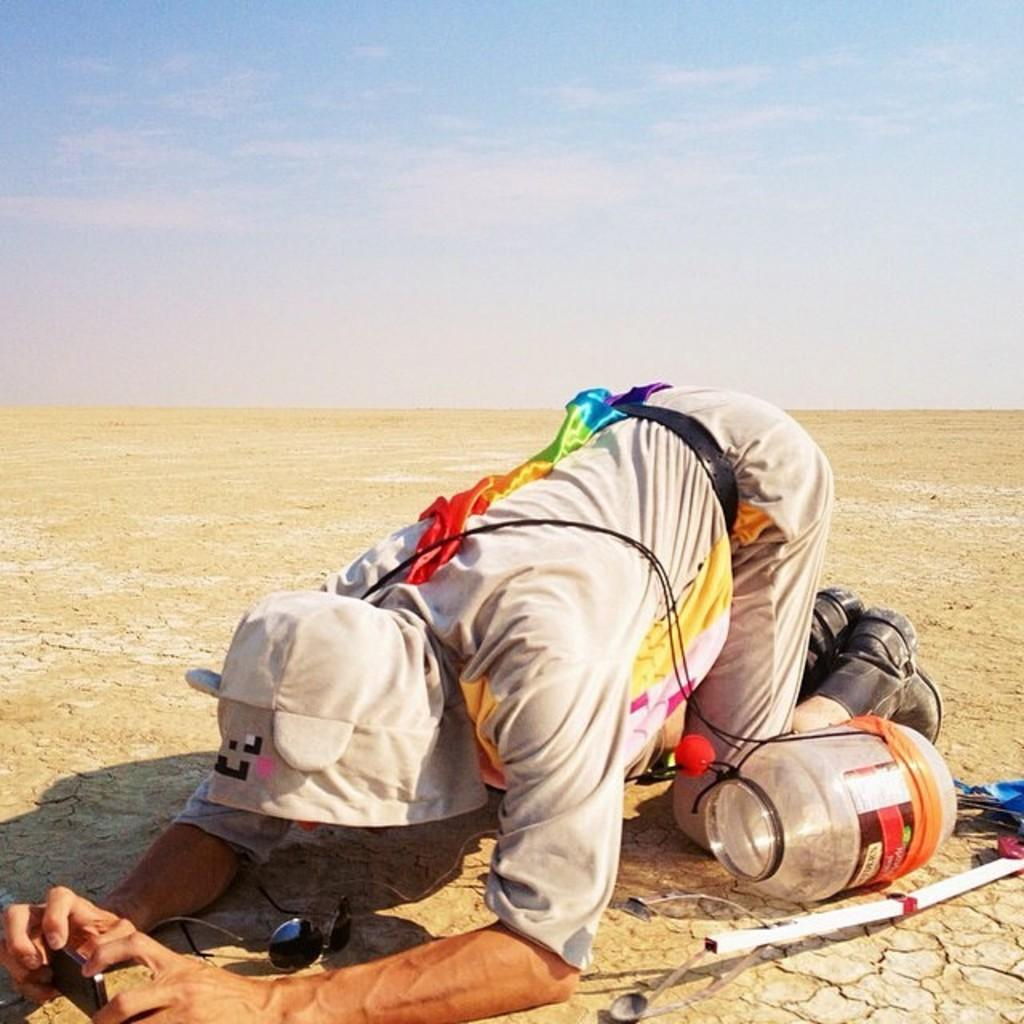Who or what is present in the image? There is a person in the image. What object is located behind the person? There is a jar behind the person. What type of protective eyewear is visible in the image? Goggles are visible in the image. What device is the person holding? The person is holding a mobile phone. What can be seen at the top of the image? The sky is visible at the top of the image. How does the person blow bubbles in the image? There is no indication of bubbles or blowing in the image. 